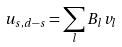Convert formula to latex. <formula><loc_0><loc_0><loc_500><loc_500>u _ { s , d - s } = \sum _ { l } B _ { l } v _ { l }</formula> 